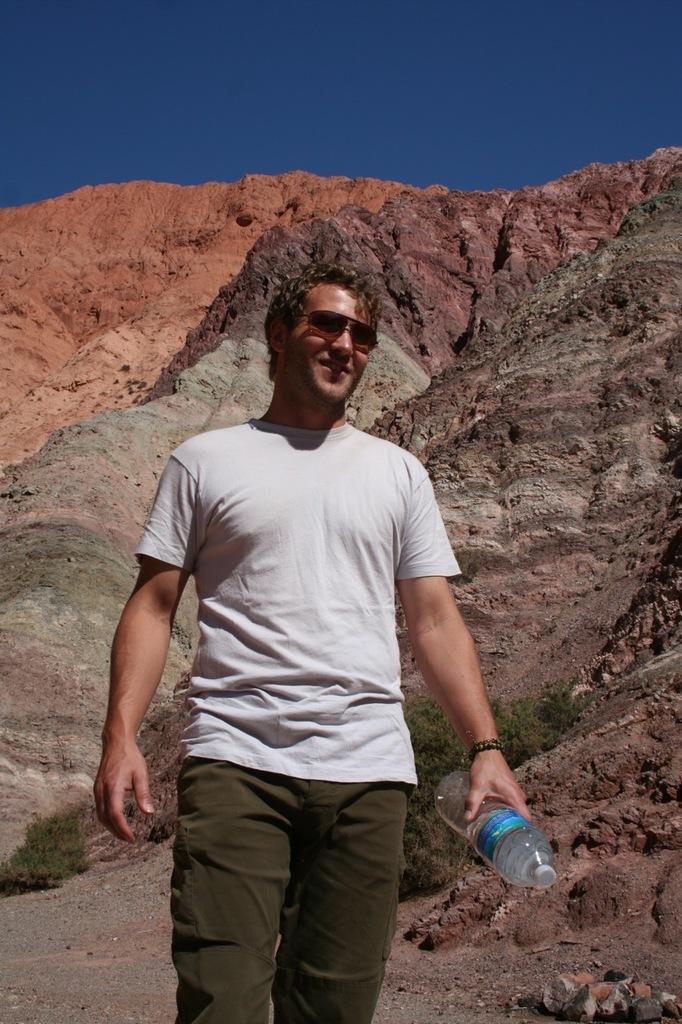Describe this image in one or two sentences. In this picture I can see a man wore sunglasses and he is holding a bottle in his hand and I can see hills on the back and a blue sky. 